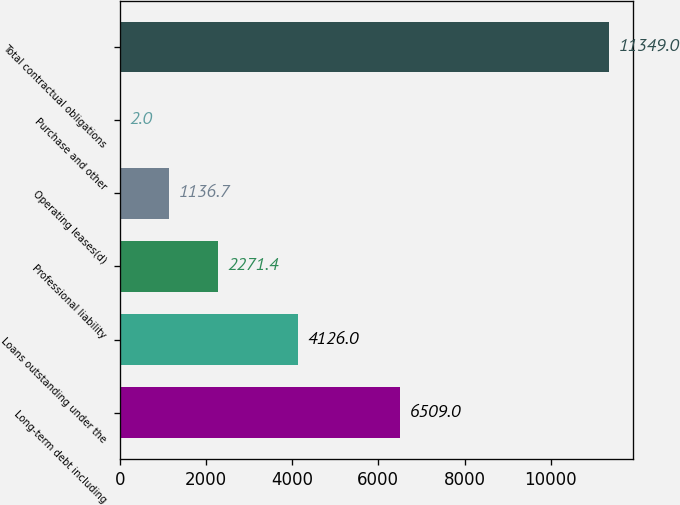Convert chart. <chart><loc_0><loc_0><loc_500><loc_500><bar_chart><fcel>Long-term debt including<fcel>Loans outstanding under the<fcel>Professional liability<fcel>Operating leases(d)<fcel>Purchase and other<fcel>Total contractual obligations<nl><fcel>6509<fcel>4126<fcel>2271.4<fcel>1136.7<fcel>2<fcel>11349<nl></chart> 